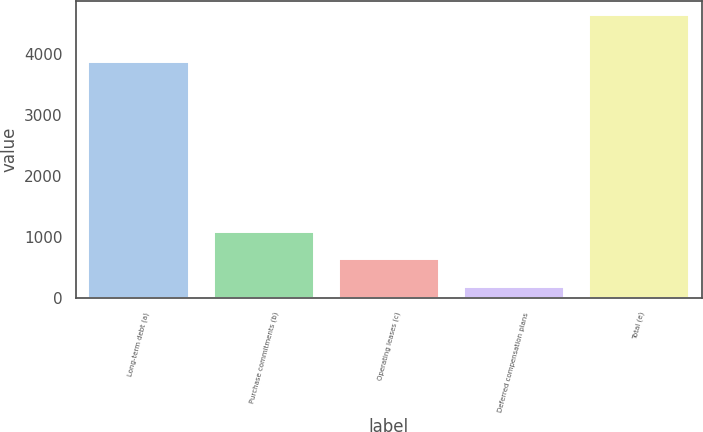<chart> <loc_0><loc_0><loc_500><loc_500><bar_chart><fcel>Long-term debt (a)<fcel>Purchase commitments (b)<fcel>Operating leases (c)<fcel>Deferred compensation plans<fcel>Total (e)<nl><fcel>3869<fcel>1081<fcel>636.5<fcel>192<fcel>4637<nl></chart> 